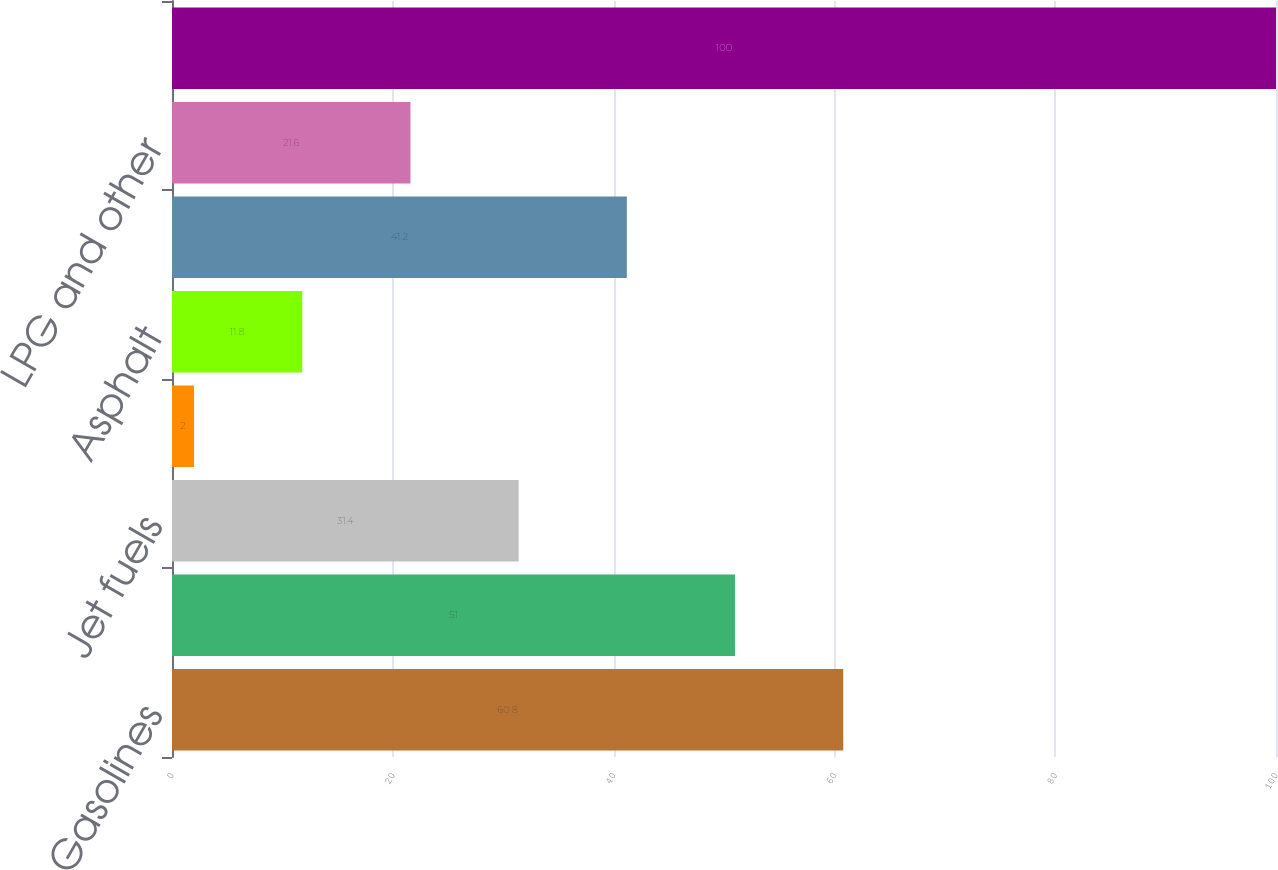<chart> <loc_0><loc_0><loc_500><loc_500><bar_chart><fcel>Gasolines<fcel>Diesel fuels<fcel>Jet fuels<fcel>Fuel oil<fcel>Asphalt<fcel>Lubricants<fcel>LPG and other<fcel>Total<nl><fcel>60.8<fcel>51<fcel>31.4<fcel>2<fcel>11.8<fcel>41.2<fcel>21.6<fcel>100<nl></chart> 